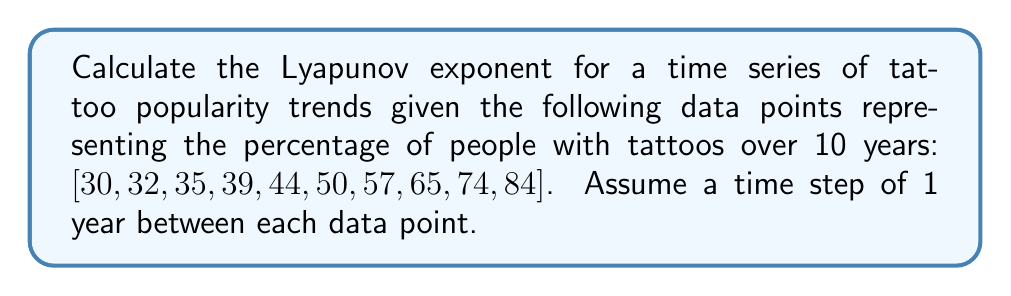Can you answer this question? To calculate the Lyapunov exponent for this time series, we'll follow these steps:

1. Calculate the differences between consecutive data points:
   $\Delta y_i = y_{i+1} - y_i$

2. Calculate the logarithm of the absolute value of these differences:
   $\ln(|\Delta y_i|)$

3. Calculate the average of these logarithms:
   $\lambda = \frac{1}{N-1} \sum_{i=1}^{N-1} \ln(|\Delta y_i|)$

where $N$ is the number of data points.

Step 1: Calculate differences
$\Delta y_1 = 32 - 30 = 2$
$\Delta y_2 = 35 - 32 = 3$
$\Delta y_3 = 39 - 35 = 4$
$\Delta y_4 = 44 - 39 = 5$
$\Delta y_5 = 50 - 44 = 6$
$\Delta y_6 = 57 - 50 = 7$
$\Delta y_7 = 65 - 57 = 8$
$\Delta y_8 = 74 - 65 = 9$
$\Delta y_9 = 84 - 74 = 10$

Step 2: Calculate logarithms
$\ln(|2|) \approx 0.6931$
$\ln(|3|) \approx 1.0986$
$\ln(|4|) \approx 1.3863$
$\ln(|5|) \approx 1.6094$
$\ln(|6|) \approx 1.7918$
$\ln(|7|) \approx 1.9459$
$\ln(|8|) \approx 2.0794$
$\ln(|9|) \approx 2.1972$
$\ln(|10|) \approx 2.3026$

Step 3: Calculate average
$$\lambda = \frac{1}{9} (0.6931 + 1.0986 + 1.3863 + 1.6094 + 1.7918 + 1.9459 + 2.0794 + 2.1972 + 2.3026)$$
$$\lambda = \frac{15.1043}{9} \approx 1.6782$$

The positive Lyapunov exponent indicates that the tattoo popularity trend is exhibiting exponential growth, suggesting a chaotic or rapidly expanding system.
Answer: $\lambda \approx 1.6782$ 